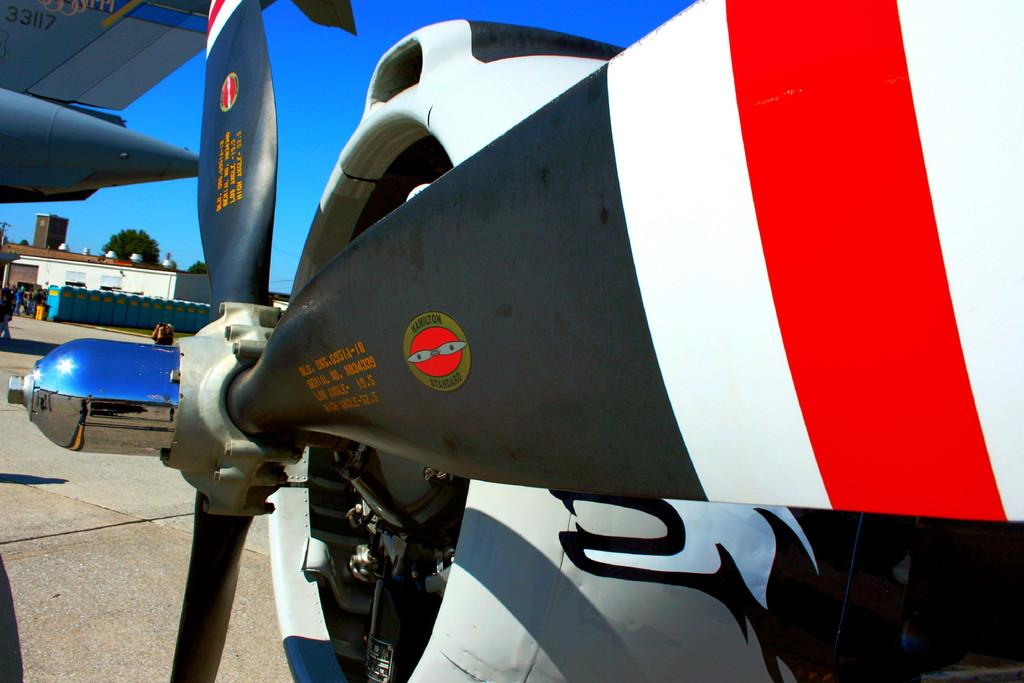<image>
Write a terse but informative summary of the picture. A Hamilton standard propeller is painted red, white and black. 